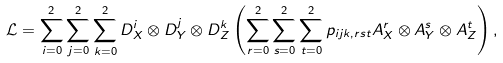<formula> <loc_0><loc_0><loc_500><loc_500>\mathcal { L } = \sum _ { i = 0 } ^ { 2 } \sum _ { j = 0 } ^ { 2 } \sum _ { k = 0 } ^ { 2 } D _ { X } ^ { i } \otimes D _ { Y } ^ { j } \otimes D _ { Z } ^ { k } \left ( \sum _ { r = 0 } ^ { 2 } \sum _ { s = 0 } ^ { 2 } \sum _ { t = 0 } ^ { 2 } p _ { i j k , r s t } A _ { X } ^ { r } \otimes A _ { Y } ^ { s } \otimes A _ { Z } ^ { t } \right ) ,</formula> 